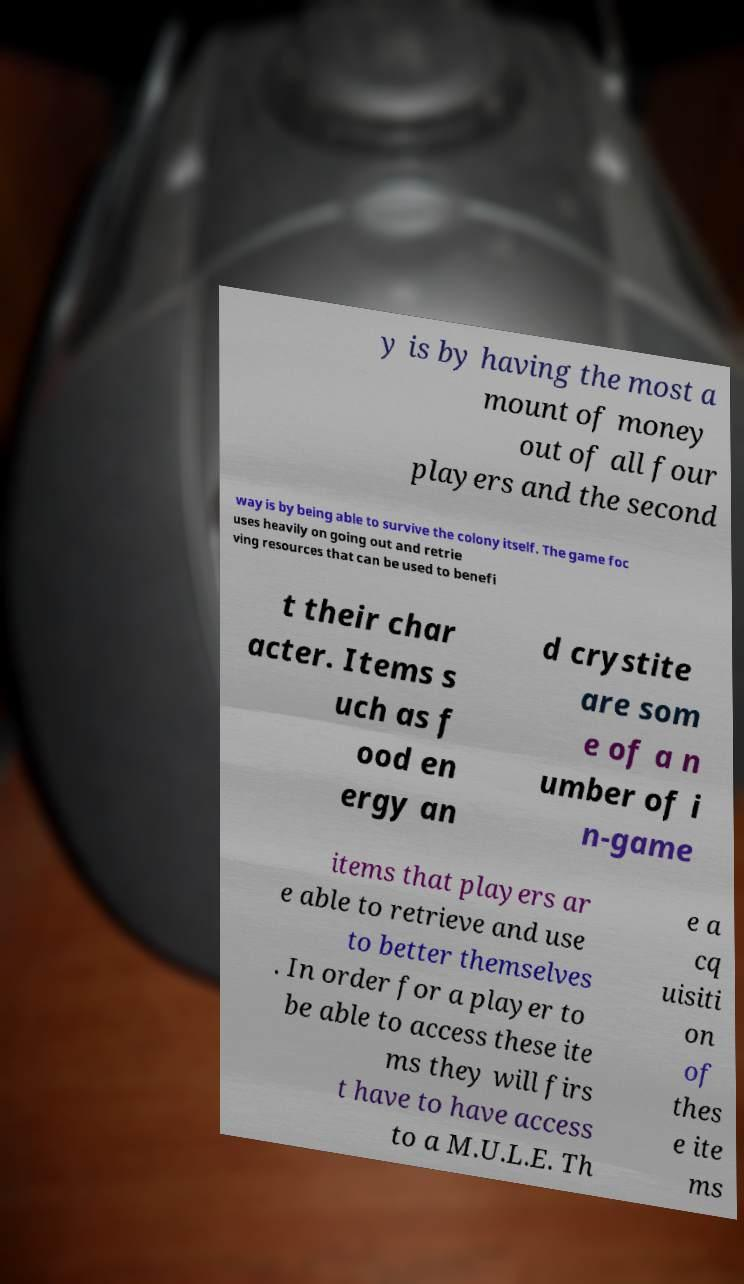Can you accurately transcribe the text from the provided image for me? y is by having the most a mount of money out of all four players and the second way is by being able to survive the colony itself. The game foc uses heavily on going out and retrie ving resources that can be used to benefi t their char acter. Items s uch as f ood en ergy an d crystite are som e of a n umber of i n-game items that players ar e able to retrieve and use to better themselves . In order for a player to be able to access these ite ms they will firs t have to have access to a M.U.L.E. Th e a cq uisiti on of thes e ite ms 